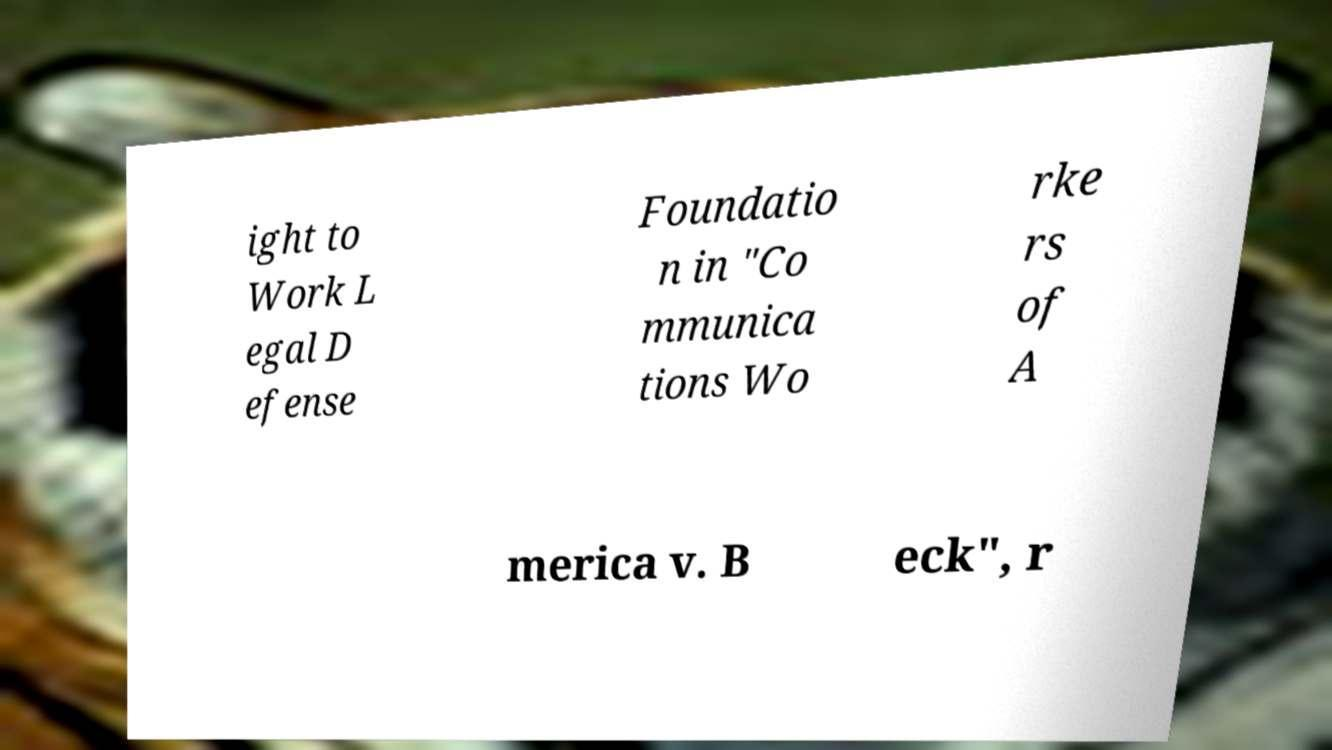Please read and relay the text visible in this image. What does it say? ight to Work L egal D efense Foundatio n in "Co mmunica tions Wo rke rs of A merica v. B eck", r 